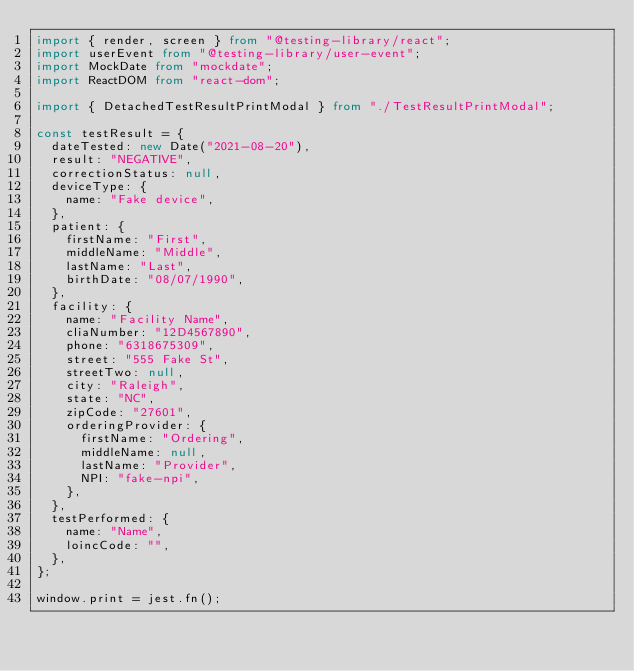<code> <loc_0><loc_0><loc_500><loc_500><_TypeScript_>import { render, screen } from "@testing-library/react";
import userEvent from "@testing-library/user-event";
import MockDate from "mockdate";
import ReactDOM from "react-dom";

import { DetachedTestResultPrintModal } from "./TestResultPrintModal";

const testResult = {
  dateTested: new Date("2021-08-20"),
  result: "NEGATIVE",
  correctionStatus: null,
  deviceType: {
    name: "Fake device",
  },
  patient: {
    firstName: "First",
    middleName: "Middle",
    lastName: "Last",
    birthDate: "08/07/1990",
  },
  facility: {
    name: "Facility Name",
    cliaNumber: "12D4567890",
    phone: "6318675309",
    street: "555 Fake St",
    streetTwo: null,
    city: "Raleigh",
    state: "NC",
    zipCode: "27601",
    orderingProvider: {
      firstName: "Ordering",
      middleName: null,
      lastName: "Provider",
      NPI: "fake-npi",
    },
  },
  testPerformed: {
    name: "Name",
    loincCode: "",
  },
};

window.print = jest.fn();
</code> 